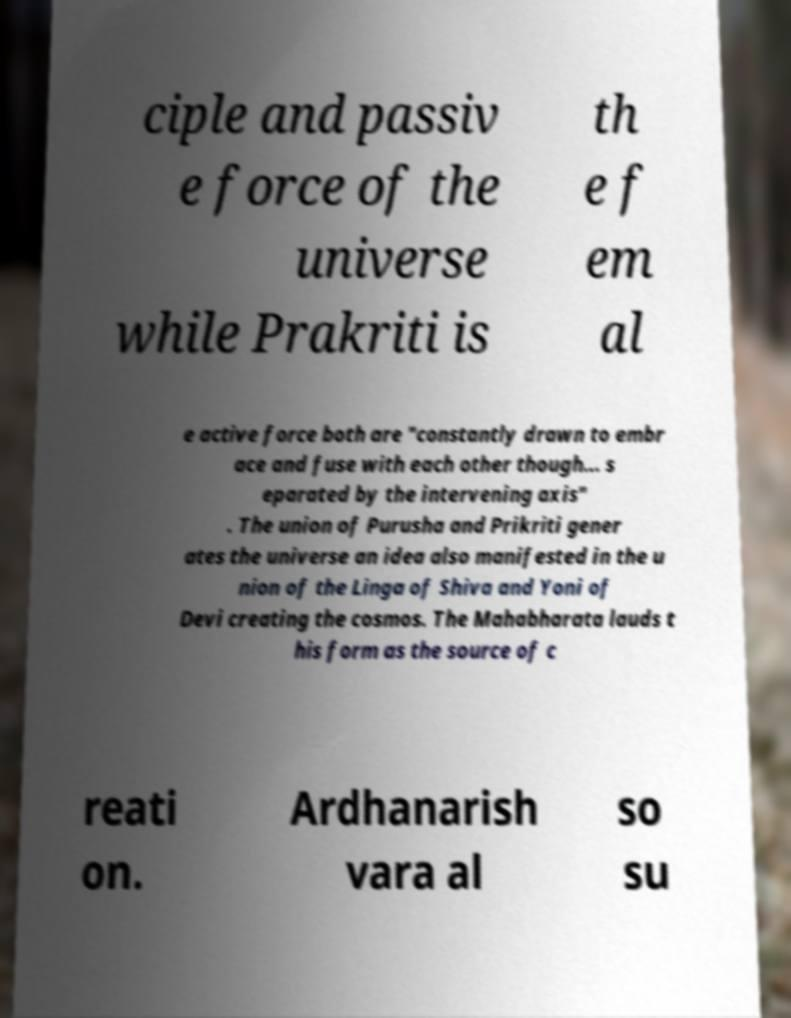Please read and relay the text visible in this image. What does it say? ciple and passiv e force of the universe while Prakriti is th e f em al e active force both are "constantly drawn to embr ace and fuse with each other though... s eparated by the intervening axis" . The union of Purusha and Prikriti gener ates the universe an idea also manifested in the u nion of the Linga of Shiva and Yoni of Devi creating the cosmos. The Mahabharata lauds t his form as the source of c reati on. Ardhanarish vara al so su 